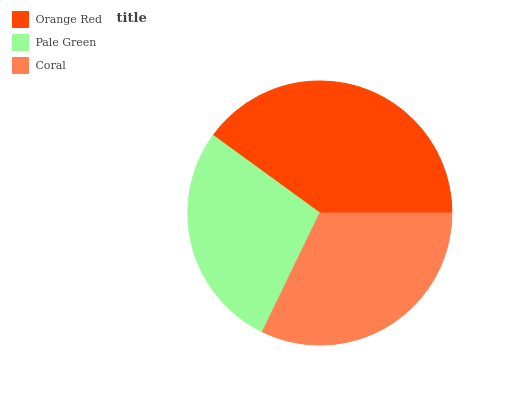Is Pale Green the minimum?
Answer yes or no. Yes. Is Orange Red the maximum?
Answer yes or no. Yes. Is Coral the minimum?
Answer yes or no. No. Is Coral the maximum?
Answer yes or no. No. Is Coral greater than Pale Green?
Answer yes or no. Yes. Is Pale Green less than Coral?
Answer yes or no. Yes. Is Pale Green greater than Coral?
Answer yes or no. No. Is Coral less than Pale Green?
Answer yes or no. No. Is Coral the high median?
Answer yes or no. Yes. Is Coral the low median?
Answer yes or no. Yes. Is Orange Red the high median?
Answer yes or no. No. Is Pale Green the low median?
Answer yes or no. No. 